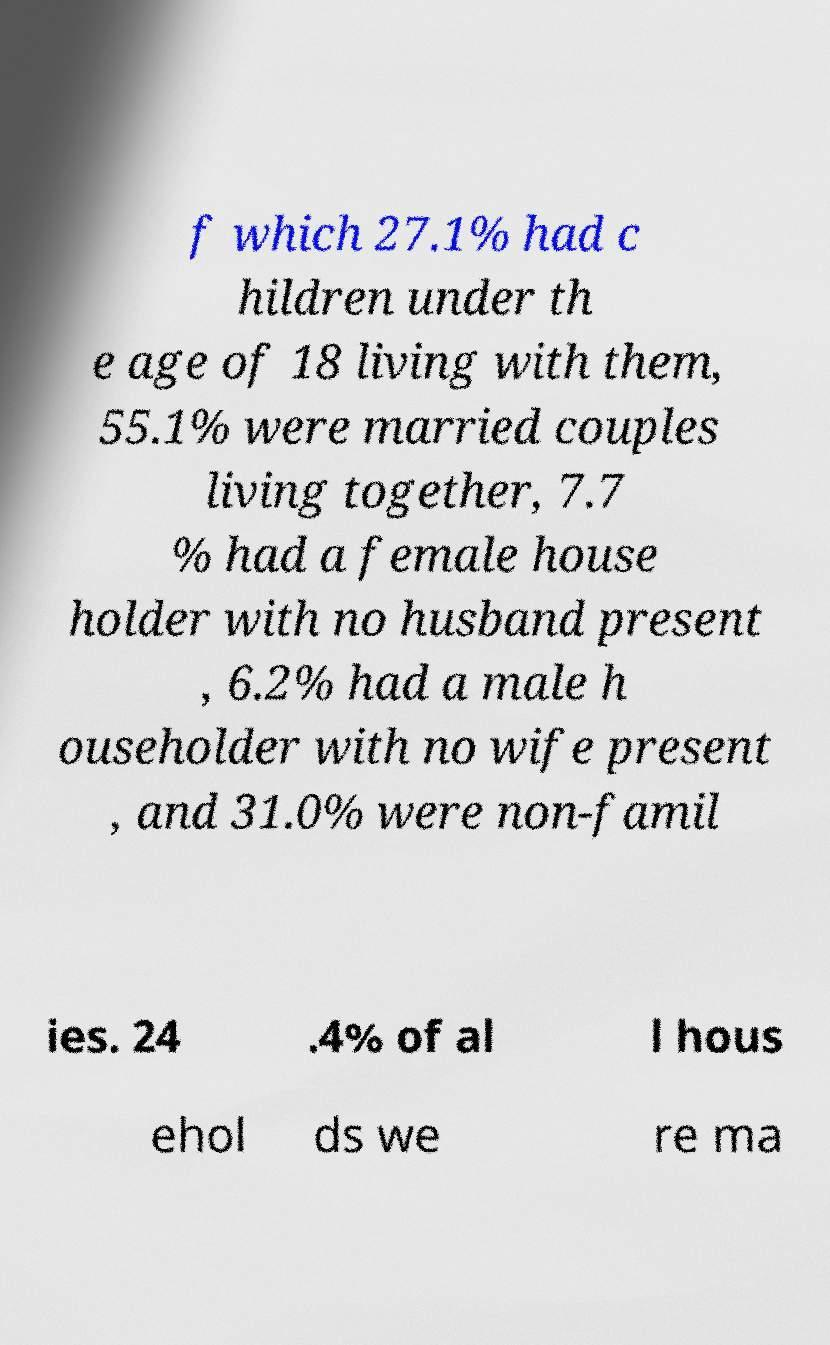What messages or text are displayed in this image? I need them in a readable, typed format. f which 27.1% had c hildren under th e age of 18 living with them, 55.1% were married couples living together, 7.7 % had a female house holder with no husband present , 6.2% had a male h ouseholder with no wife present , and 31.0% were non-famil ies. 24 .4% of al l hous ehol ds we re ma 